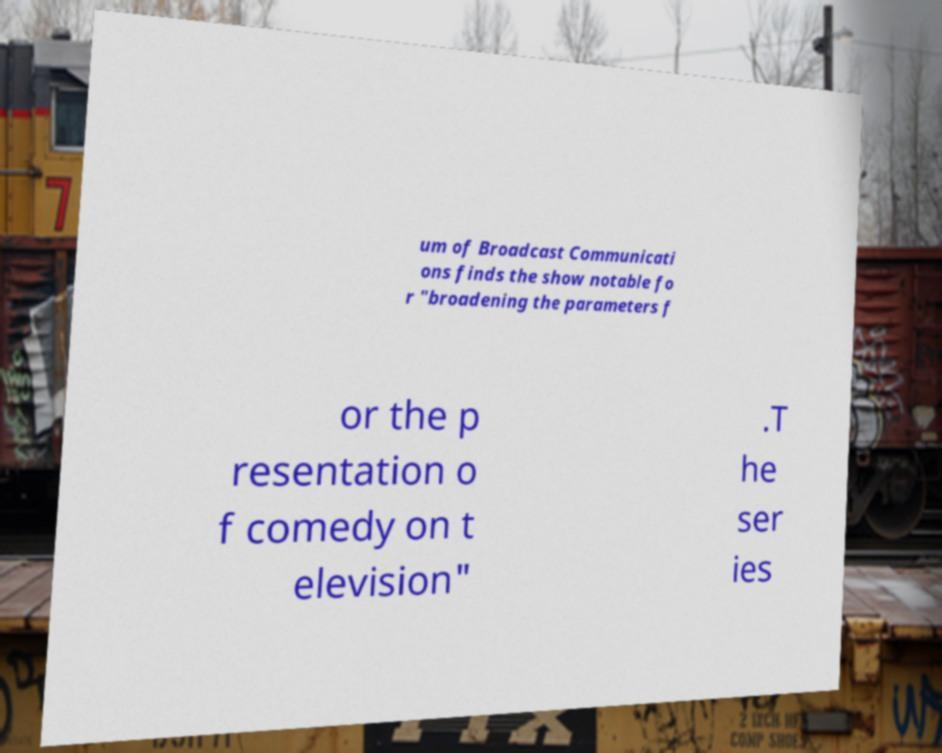Could you extract and type out the text from this image? um of Broadcast Communicati ons finds the show notable fo r "broadening the parameters f or the p resentation o f comedy on t elevision" .T he ser ies 